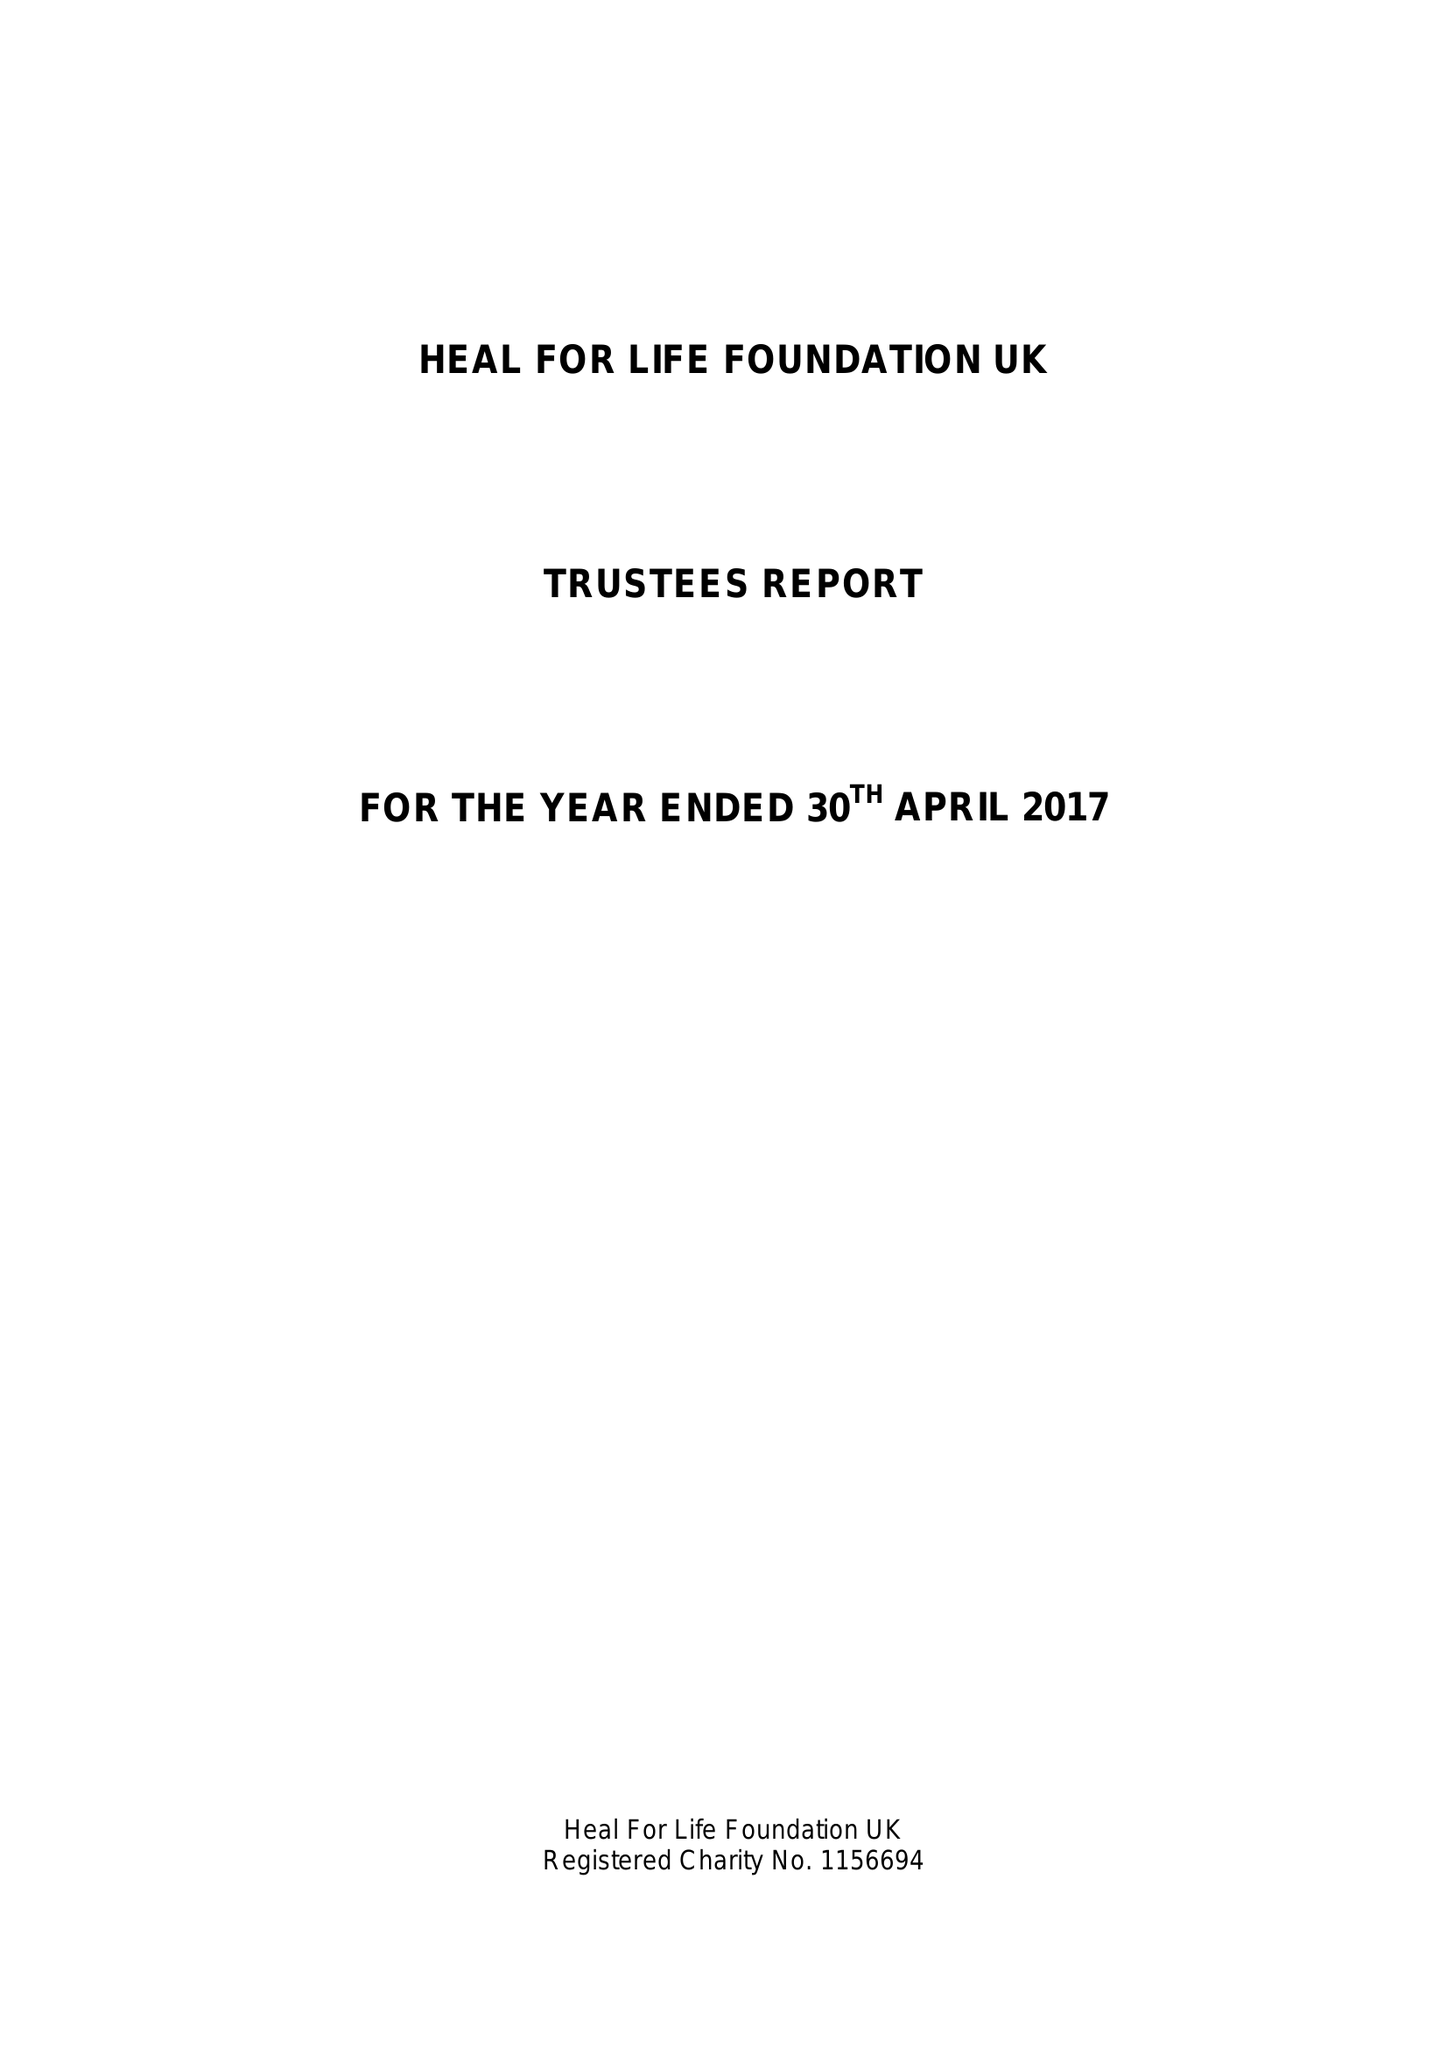What is the value for the report_date?
Answer the question using a single word or phrase. 2017-04-30 